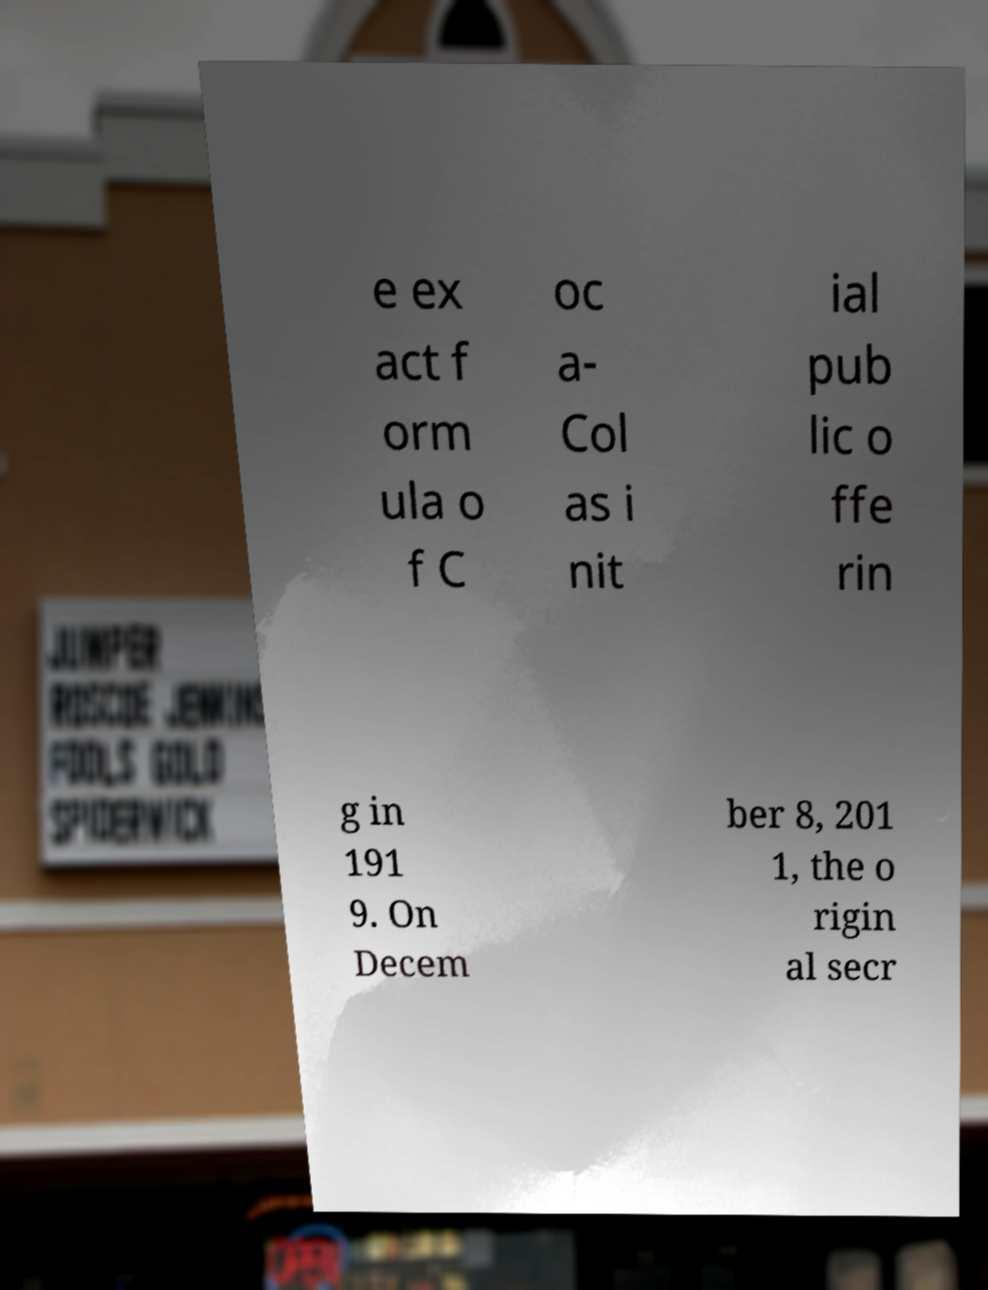What messages or text are displayed in this image? I need them in a readable, typed format. e ex act f orm ula o f C oc a- Col as i nit ial pub lic o ffe rin g in 191 9. On Decem ber 8, 201 1, the o rigin al secr 